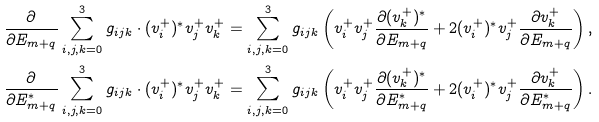<formula> <loc_0><loc_0><loc_500><loc_500>\frac { \partial } { \partial E _ { m + q } } \sum _ { i , j , k = 0 } ^ { 3 } g _ { i j k } \cdot ( v _ { i } ^ { + } ) ^ { * } v _ { j } ^ { + } v _ { k } ^ { + } & = \sum _ { i , j , k = 0 } ^ { 3 } g _ { i j k } \left ( v _ { i } ^ { + } v _ { j } ^ { + } \frac { \partial ( v _ { k } ^ { + } ) ^ { * } } { \partial E _ { m + q } } + 2 ( v _ { i } ^ { + } ) ^ { * } v _ { j } ^ { + } \frac { \partial v _ { k } ^ { + } } { \partial E _ { m + q } } \right ) , \\ \frac { \partial } { \partial E _ { m + q } ^ { * } } \sum _ { i , j , k = 0 } ^ { 3 } g _ { i j k } \cdot ( v _ { i } ^ { + } ) ^ { * } v _ { j } ^ { + } v _ { k } ^ { + } & = \sum _ { i , j , k = 0 } ^ { 3 } g _ { i j k } \left ( v _ { i } ^ { + } v _ { j } ^ { + } \frac { \partial ( v _ { k } ^ { + } ) ^ { * } } { \partial E _ { m + q } ^ { * } } + 2 ( v _ { i } ^ { + } ) ^ { * } v _ { j } ^ { + } \frac { \partial v _ { k } ^ { + } } { \partial E _ { m + q } ^ { * } } \right ) .</formula> 